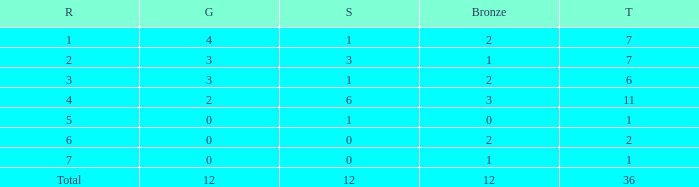What is the number of bronze medals when there are fewer than 0 silver medals? None. 